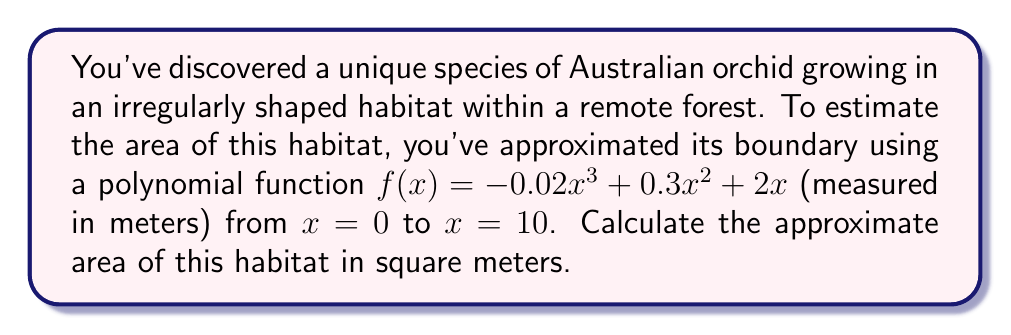What is the answer to this math problem? To estimate the area of the irregularly shaped habitat, we need to calculate the definite integral of the given polynomial function from $x = 0$ to $x = 10$. This process involves the following steps:

1) The given function is $f(x) = -0.02x^3 + 0.3x^2 + 2x$

2) To find the area, we need to integrate this function:

   $$A = \int_0^{10} (-0.02x^3 + 0.3x^2 + 2x) dx$$

3) Integrate each term:
   $$\int (-0.02x^3) dx = -0.005x^4$$
   $$\int (0.3x^2) dx = 0.1x^3$$
   $$\int (2x) dx = x^2$$

4) The indefinite integral is:
   $$-0.005x^4 + 0.1x^3 + x^2 + C$$

5) Now, we need to apply the limits of integration:

   $$A = [-0.005x^4 + 0.1x^3 + x^2]_0^{10}$$

6) Evaluate at $x = 10$:
   $$-0.005(10^4) + 0.1(10^3) + 10^2 = -500 + 1000 + 100 = 600$$

7) Evaluate at $x = 0$:
   $$-0.005(0^4) + 0.1(0^3) + 0^2 = 0$$

8) Subtract the lower limit from the upper limit:
   $$600 - 0 = 600$$

Therefore, the approximate area of the habitat is 600 square meters.
Answer: 600 square meters 